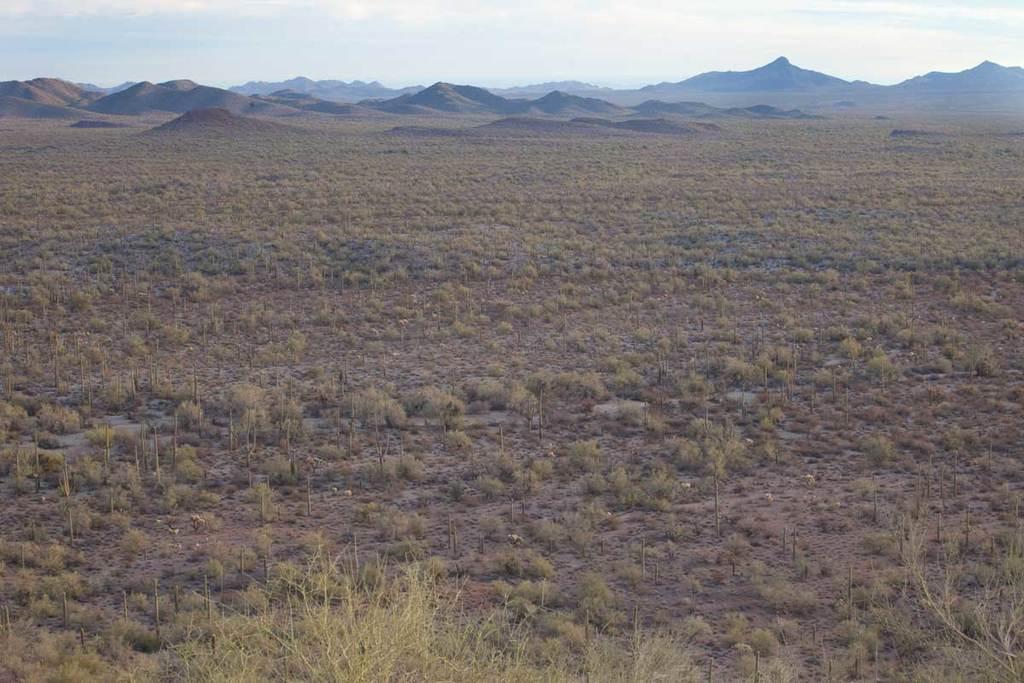How would you summarize this image in a sentence or two? In the image in the center we can see the sky,clouds,hills and grass. 